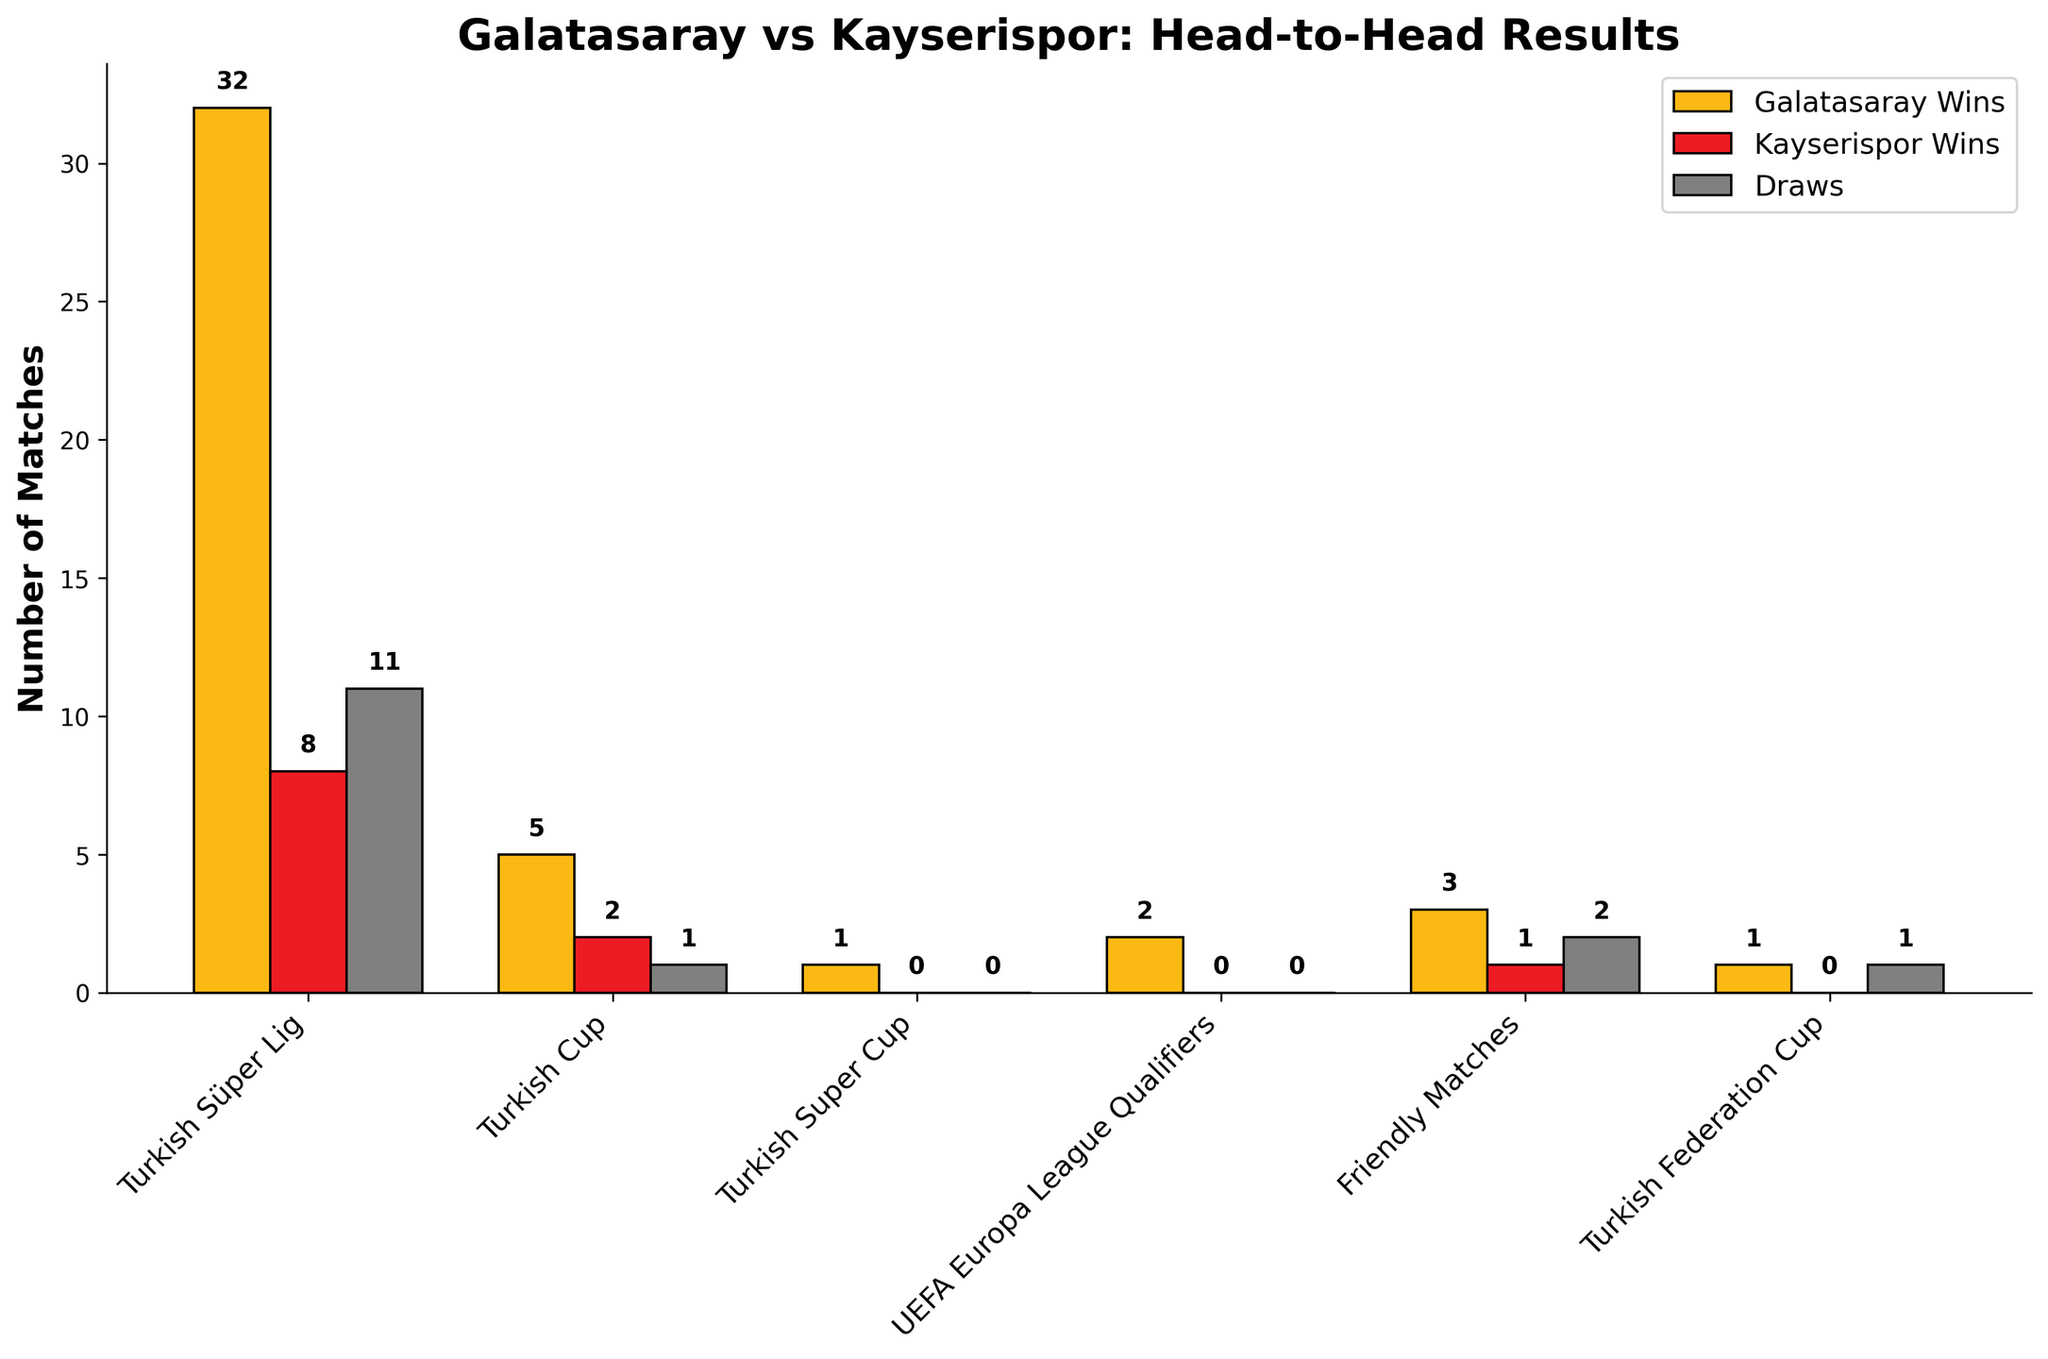What is the total number of matches played between Galatasaray and Kayserispor in the Turkish Süper Lig? To find the total number of matches played, sum Galatasaray wins, Kayserispor wins, and draws in the Turkish Süper Lig: 32 + 8 + 11.
Answer: 51 How many more matches has Galatasaray won than Kayserispor in all the competitions combined? First, add up the total wins for Galatasaray across all competitions: 32 + 5 + 1 + 2 + 3 + 1 = 44. Then, do the same for Kayserispor: 8 + 2 + 0 + 0 + 1 + 0 = 11. Subtract the total wins of Kayserispor from Galatasaray: 44 - 11.
Answer: 33 Which competition shows the highest number of matches that ended in a draw? Compare the number of draws in each competition. Turkish Süper Lig has the highest number of draws at 11.
Answer: Turkish Süper Lig Is there any competition where Kayserispor hasn't won a single match against Galatasaray? Check for competitions where Kayserispor wins are 0: Turkish Super Cup, UEFA Europa League Qualifiers, and Turkish Federation Cup.
Answer: Yes How many total head-to-head matches took place in the Turkish Cup? Add the wins for both Galatasaray and Kayserispor and the draws in the Turkish Cup: 5 + 2 + 1.
Answer: 8 What is the color of the bar representing Galatasaray wins? The color used for Galatasaray wins is observed to be yellow.
Answer: Yellow How many wins does Galatasaray have in competitions other than the Turkish Süper Lig? Add up Galatasaray's wins in the remaining competitions: 5 + 1 + 2 + 3 + 1.
Answer: 12 In which competition is the difference in wins between Galatasaray and Kayserispor the smallest? Calculate the absolute difference in wins for each competition and find the smallest difference: Turkish Süper Lig (32-8=24), Turkish Cup (5-2=3), Turkish Super Cup (1-0=1), UEFA Europa League Qualifiers (2-0=2), Friendly Matches (3-1=2), Turkish Federation Cup (1-0=1). The smallest difference is in the Turkish Super Cup and the Turkish Federation Cup.
Answer: Turkish Super Cup or Turkish Federation Cup How many fewer matches ended in draws compared to matches won by Galatasaray in the Turkish Cup? Find Galatasaray's wins in the Turkish Cup: 5. Find draws in the Turkish Cup: 1. Calculate the difference: 5 - 1.
Answer: 4 Between Galatasaray and Kayserispor, which team has won more matches in Friendly Matches? Compare Galatasaray wins (3) to Kayserispor wins (1) in Friendly Matches.
Answer: Galatasaray 